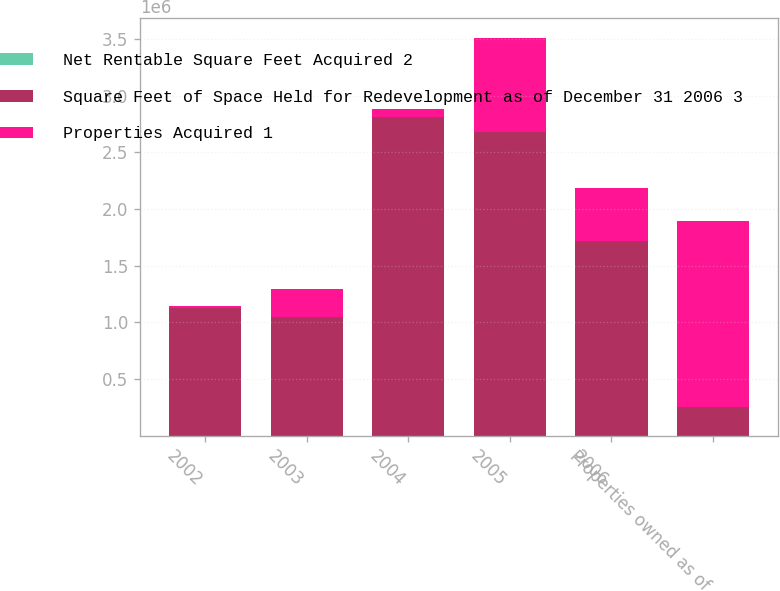Convert chart. <chart><loc_0><loc_0><loc_500><loc_500><stacked_bar_chart><ecel><fcel>2002<fcel>2003<fcel>2004<fcel>2005<fcel>2006<fcel>Properties owned as of<nl><fcel>Net Rentable Square Feet Acquired 2<fcel>5<fcel>7<fcel>11<fcel>20<fcel>16<fcel>59<nl><fcel>Square Feet of Space Held for Redevelopment as of December 31 2006 3<fcel>1.12529e+06<fcel>1.04608e+06<fcel>2.81183e+06<fcel>2.68081e+06<fcel>1.71786e+06<fcel>252436<nl><fcel>Properties Acquired 1<fcel>19890<fcel>252436<fcel>71640<fcel>832252<fcel>470037<fcel>1.64626e+06<nl></chart> 